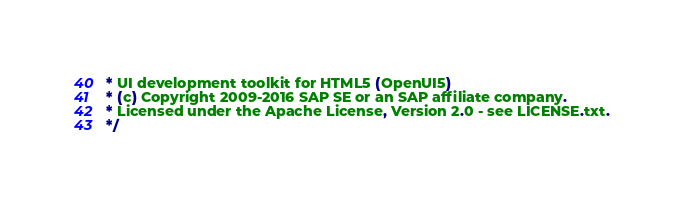<code> <loc_0><loc_0><loc_500><loc_500><_CSS_> * UI development toolkit for HTML5 (OpenUI5)
 * (c) Copyright 2009-2016 SAP SE or an SAP affiliate company.
 * Licensed under the Apache License, Version 2.0 - see LICENSE.txt.
 */</code> 